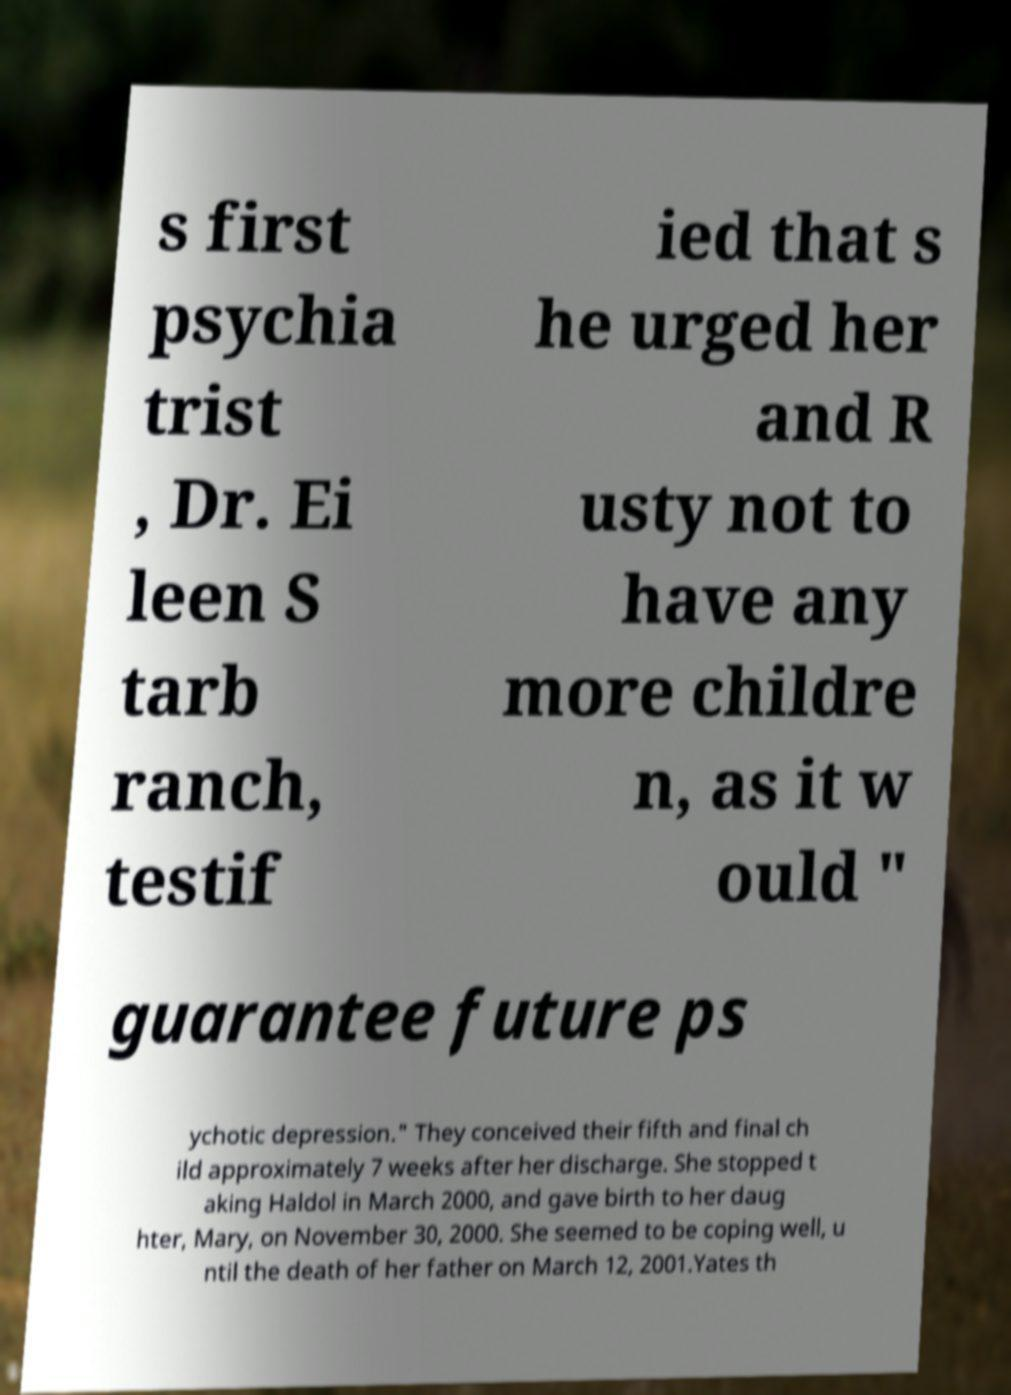For documentation purposes, I need the text within this image transcribed. Could you provide that? s first psychia trist , Dr. Ei leen S tarb ranch, testif ied that s he urged her and R usty not to have any more childre n, as it w ould " guarantee future ps ychotic depression." They conceived their fifth and final ch ild approximately 7 weeks after her discharge. She stopped t aking Haldol in March 2000, and gave birth to her daug hter, Mary, on November 30, 2000. She seemed to be coping well, u ntil the death of her father on March 12, 2001.Yates th 